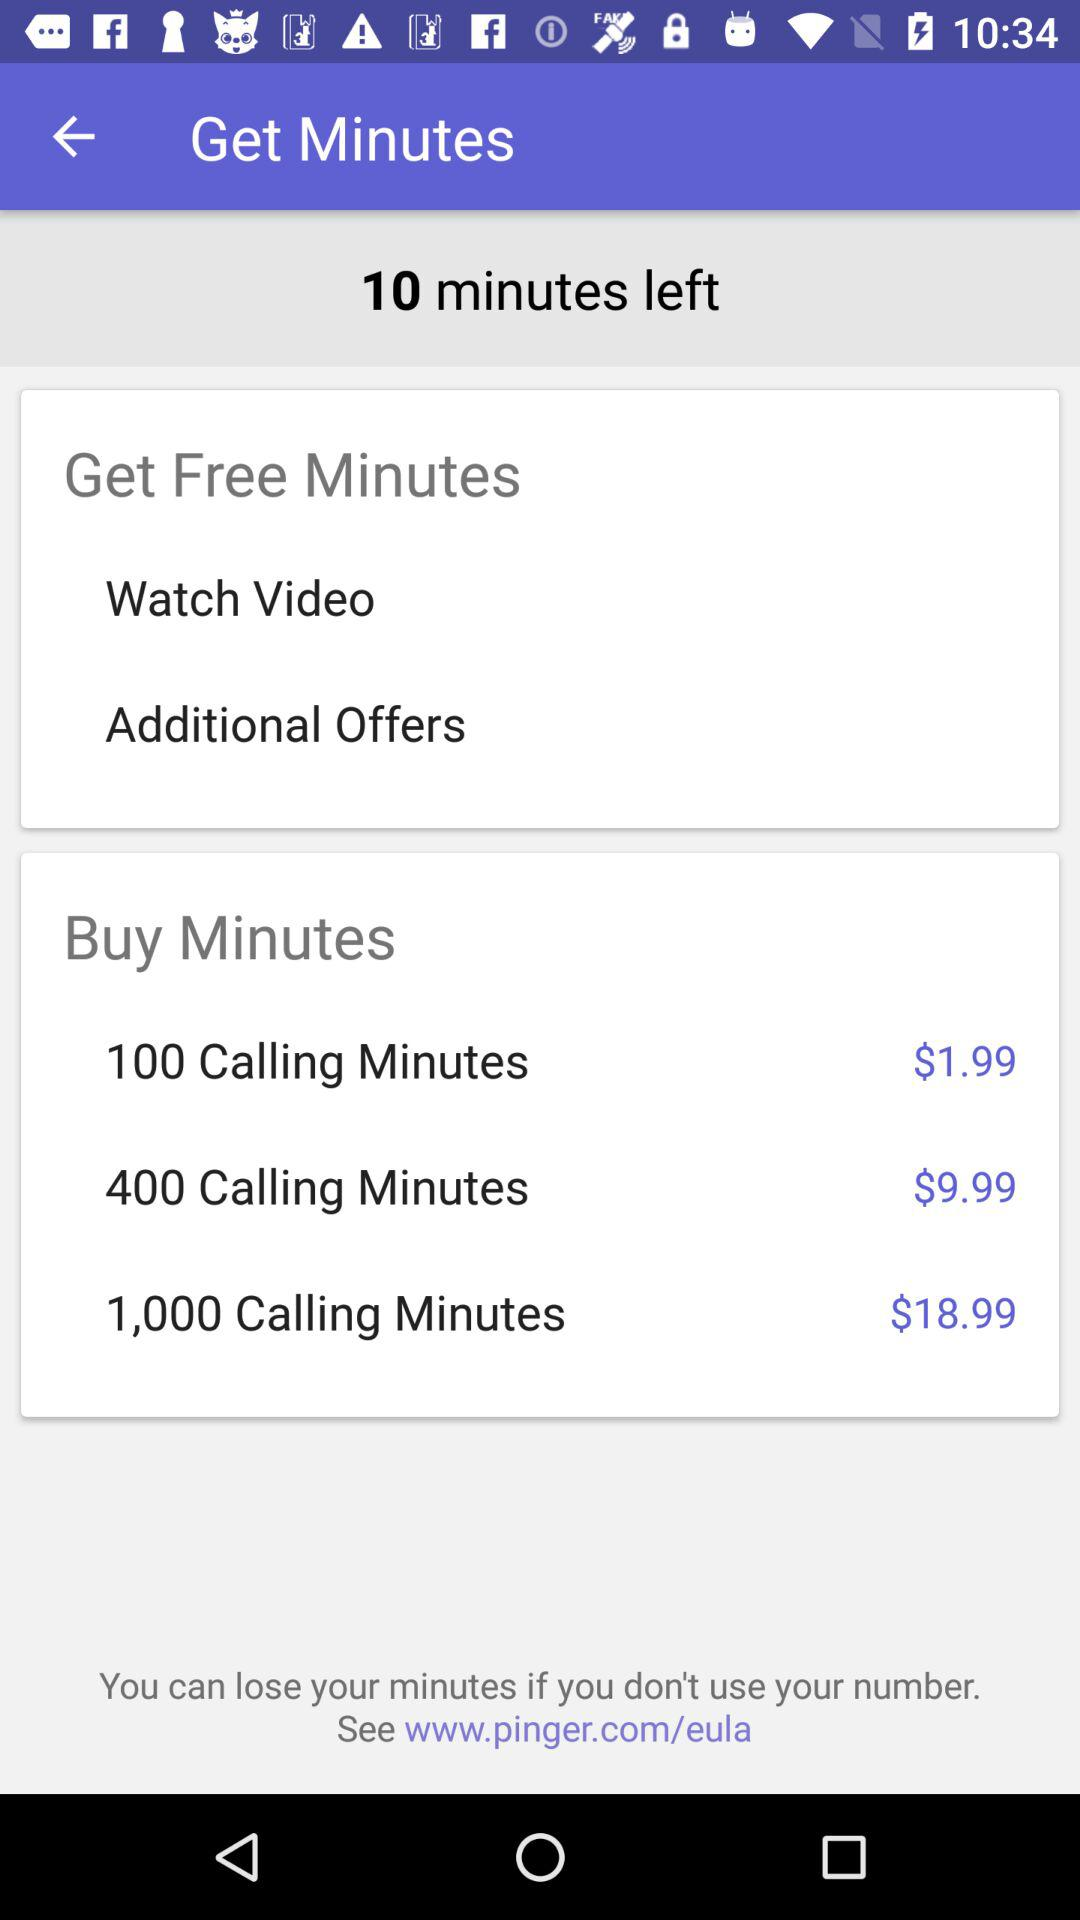What is the website address? The website address is www.pinger.com/eula. 